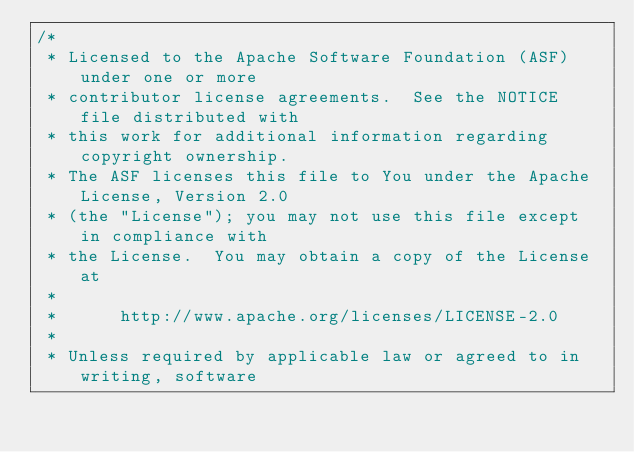<code> <loc_0><loc_0><loc_500><loc_500><_Java_>/*
 * Licensed to the Apache Software Foundation (ASF) under one or more
 * contributor license agreements.  See the NOTICE file distributed with
 * this work for additional information regarding copyright ownership.
 * The ASF licenses this file to You under the Apache License, Version 2.0
 * (the "License"); you may not use this file except in compliance with
 * the License.  You may obtain a copy of the License at
 *
 *      http://www.apache.org/licenses/LICENSE-2.0
 *
 * Unless required by applicable law or agreed to in writing, software</code> 